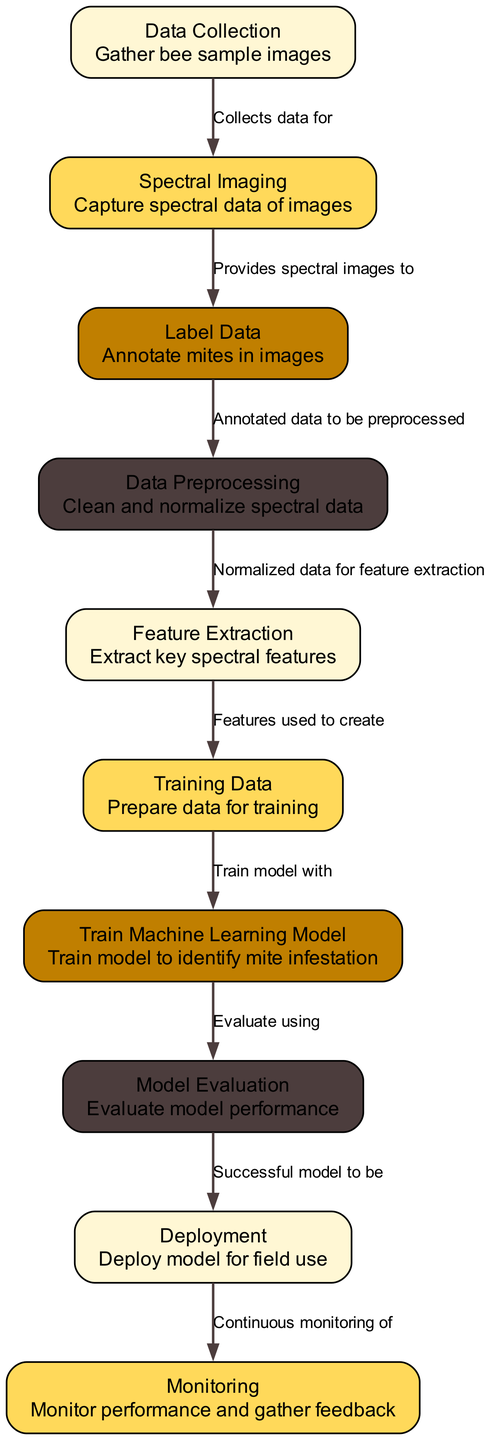What is the first step in the diagram? The first step is labeled 'Data Collection', which indicates that the process begins with gathering bee sample images.
Answer: Data Collection How many nodes are present in the diagram? By counting the nodes listed, there are a total of 10 nodes in the diagram, each representing a different stage in the machine learning process.
Answer: 10 What data is provided to the 'Label Data' node? The 'Spectral Imaging' node provides spectral images to the 'Label Data' node for annotation of mites in the images.
Answer: Spectral images Which node follows 'Monitoring' in the diagram? The 'Deployment' node precedes 'Monitoring', indicating that monitoring is done after the model has been deployed for field use.
Answer: Deployment What is the main purpose of 'Feature Extraction'? The 'Feature Extraction' node is focused on extracting key spectral features from the normalized data to prepare for training the machine learning model.
Answer: Extract key spectral features What is required after 'Model Evaluation'? After evaluating the model performance, the successful model is then prepared for deployment for field use.
Answer: Deployment What illustrates the relationship between 'Data Preprocessing' and 'Feature Extraction'? The relationship is shown by an edge connecting 'Data Preprocessing' to 'Feature Extraction', indicating that normalized data from preprocessing is used for extracting features.
Answer: Normalized data Which two nodes are connected directly to 'Train Machine Learning Model'? 'Training Data' and 'Model Evaluation' are directly connected to 'Train Machine Learning Model', indicating that training occurs on prepared data and evaluates the model’s performance afterward.
Answer: Training Data, Model Evaluation What do the nodes represent in this diagram? Each node in the diagram represents a specific step or stage in the process of using machine learning to identify bee mite infestation levels using spectral analysis.
Answer: Steps or stages in the process 